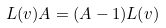Convert formula to latex. <formula><loc_0><loc_0><loc_500><loc_500>L ( v ) A = ( A - 1 ) L ( v )</formula> 